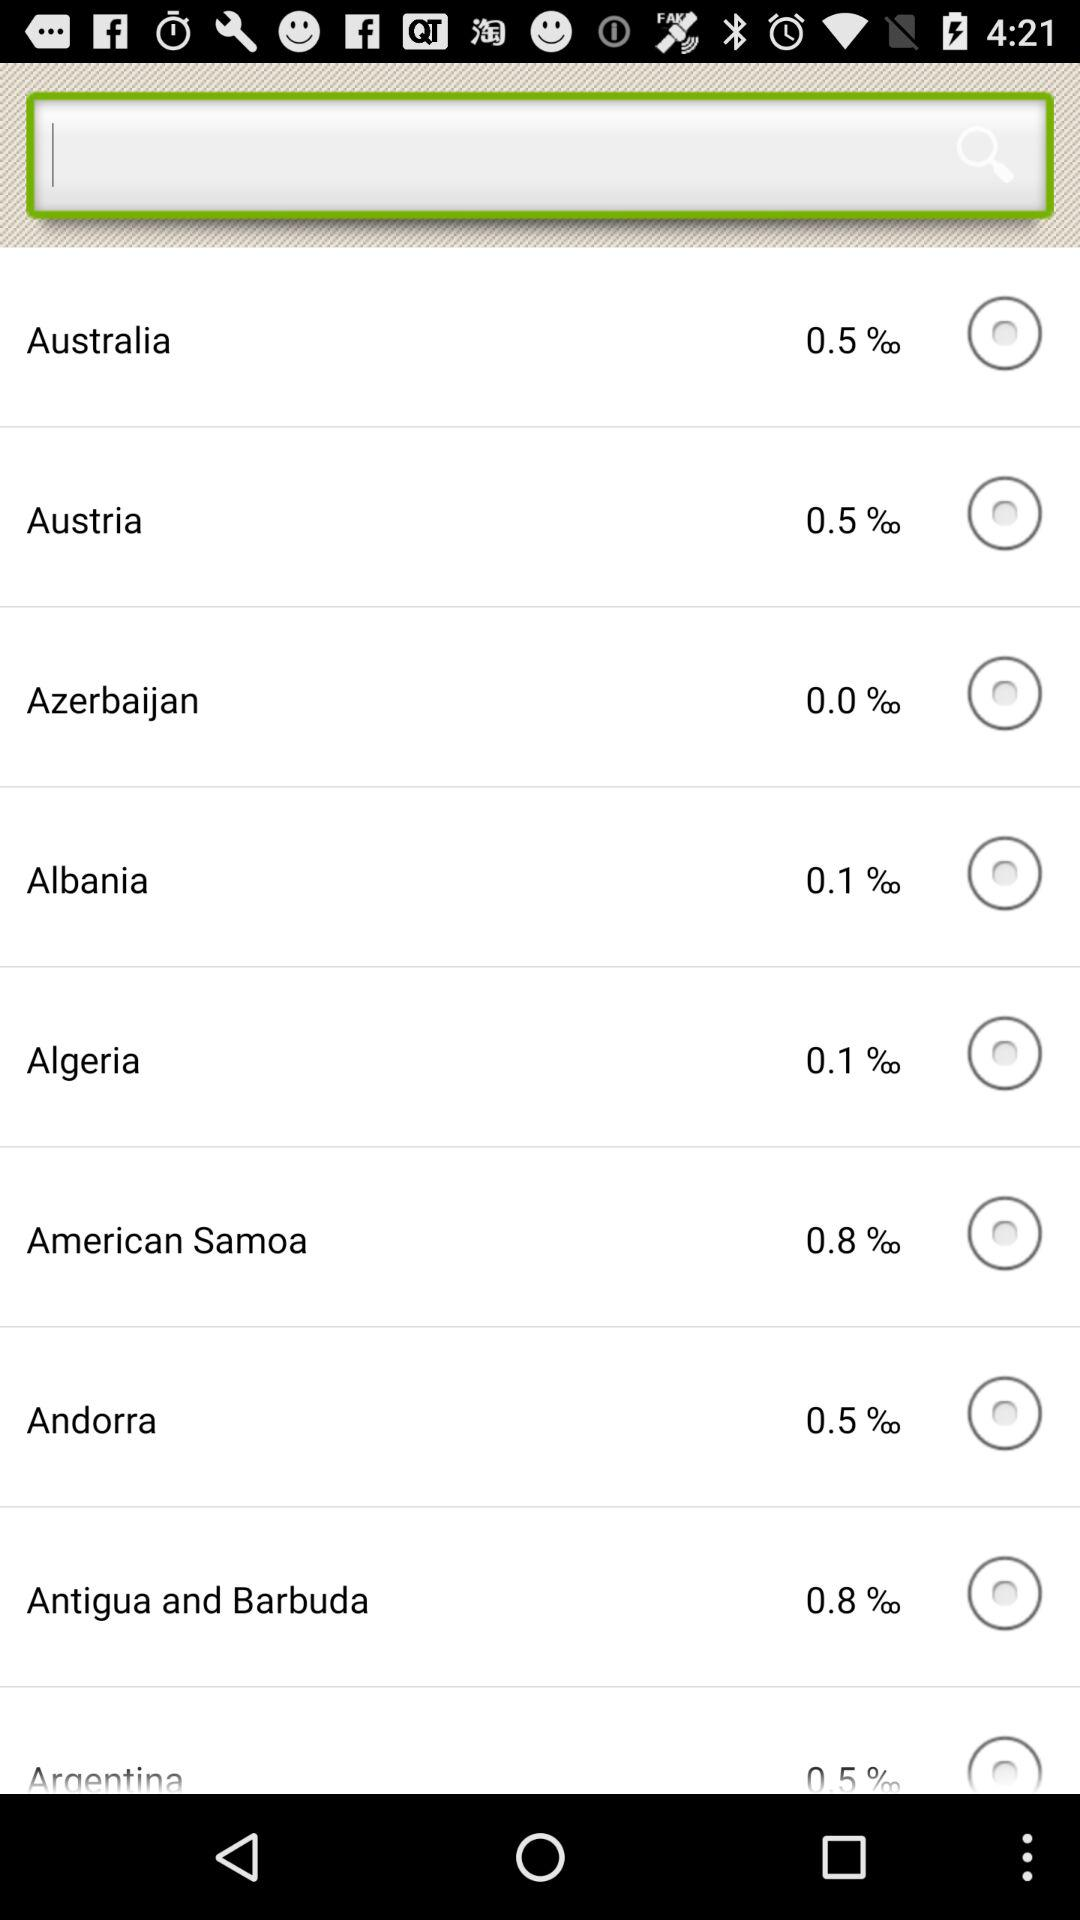What is the percentage of Algeria? The percentage of Algeria is 0.1. 